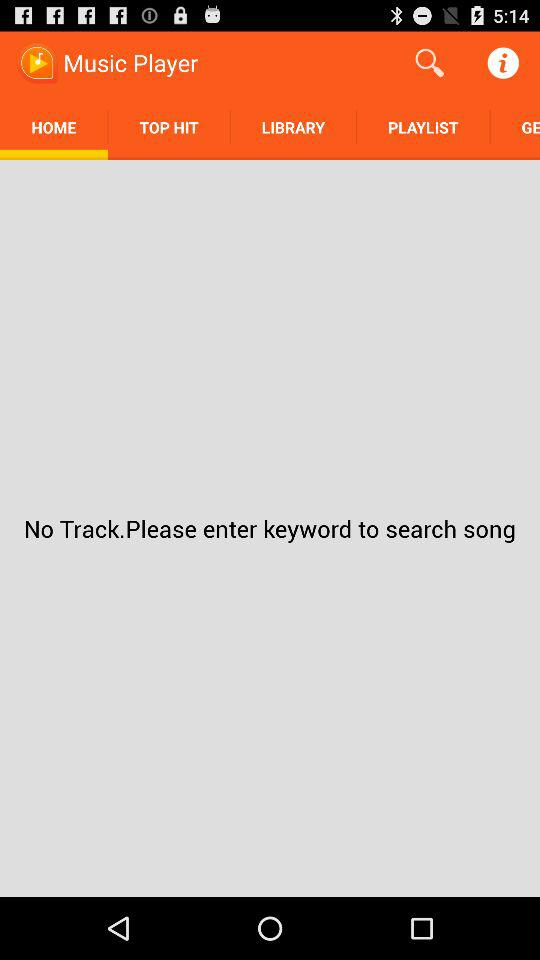On which tab am I now? Now, you are on the "Home" tab. 